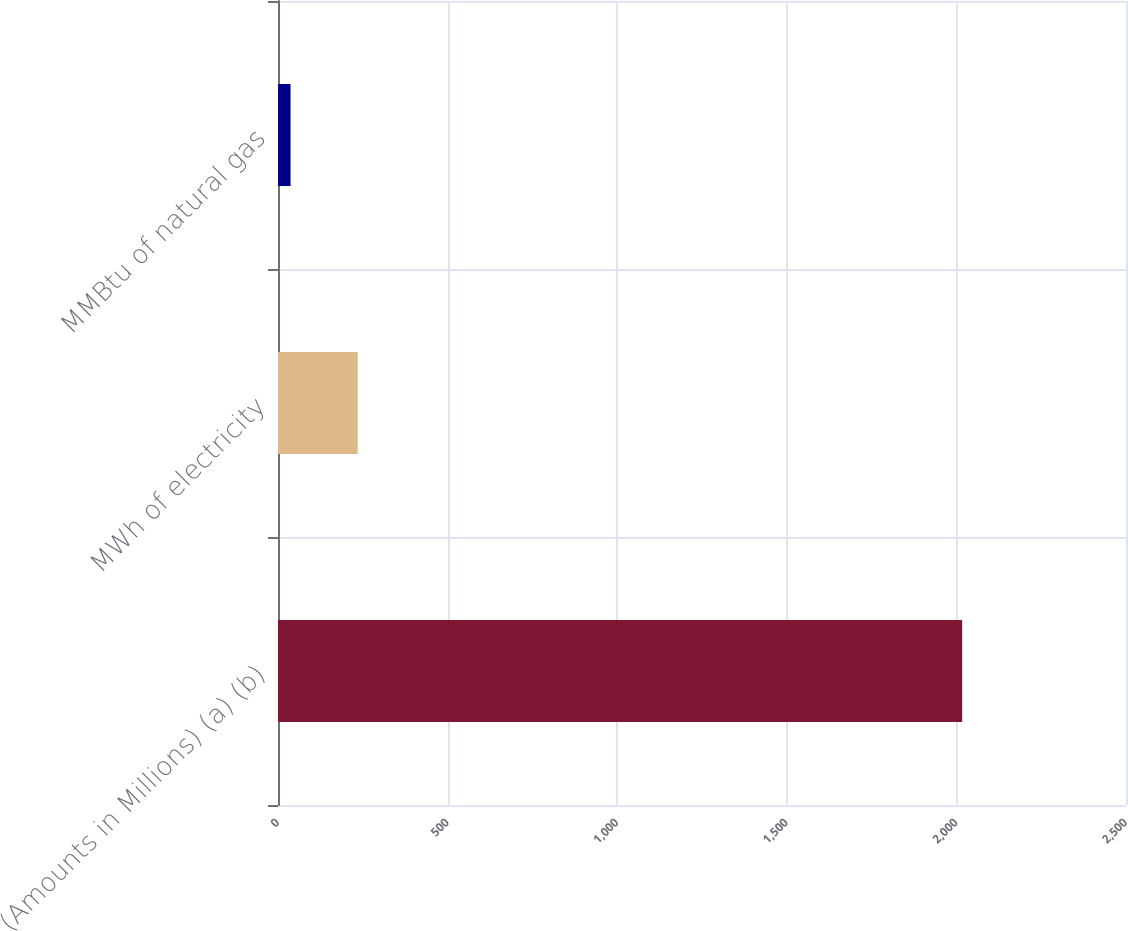<chart> <loc_0><loc_0><loc_500><loc_500><bar_chart><fcel>(Amounts in Millions) (a) (b)<fcel>MWh of electricity<fcel>MMBtu of natural gas<nl><fcel>2017<fcel>235<fcel>37<nl></chart> 